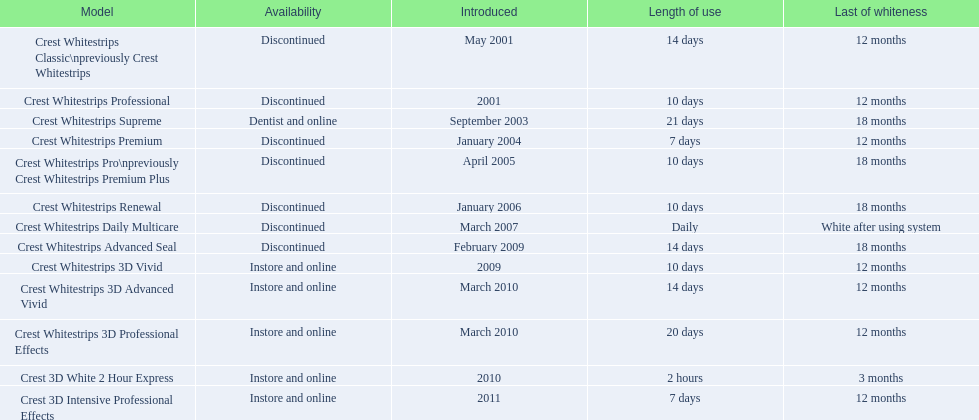What are all the designs? Crest Whitestrips Classic\npreviously Crest Whitestrips, Crest Whitestrips Professional, Crest Whitestrips Supreme, Crest Whitestrips Premium, Crest Whitestrips Pro\npreviously Crest Whitestrips Premium Plus, Crest Whitestrips Renewal, Crest Whitestrips Daily Multicare, Crest Whitestrips Advanced Seal, Crest Whitestrips 3D Vivid, Crest Whitestrips 3D Advanced Vivid, Crest Whitestrips 3D Professional Effects, Crest 3D White 2 Hour Express, Crest 3D Intensive Professional Effects. From these, for which can a fraction be calculated for 'period of use' to 'termination of whiteness'? Crest Whitestrips Classic\npreviously Crest Whitestrips, Crest Whitestrips Professional, Crest Whitestrips Supreme, Crest Whitestrips Premium, Crest Whitestrips Pro\npreviously Crest Whitestrips Premium Plus, Crest Whitestrips Renewal, Crest Whitestrips Advanced Seal, Crest Whitestrips 3D Vivid, Crest Whitestrips 3D Advanced Vivid, Crest Whitestrips 3D Professional Effects, Crest 3D White 2 Hour Express, Crest 3D Intensive Professional Effects. Which has the top fraction? Crest Whitestrips Supreme. 